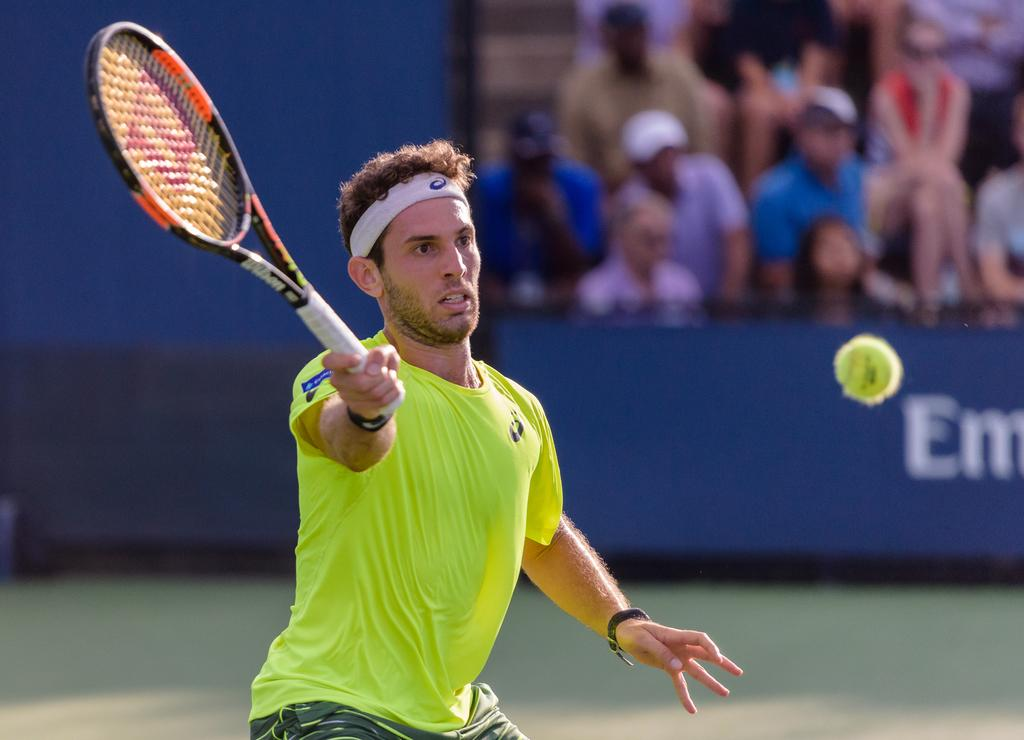What activity is the person in the image engaged in? The person is playing tennis in the image. What is the tennis ball doing in the image? The tennis ball is flying in the air. How is the person holding the tennis bat? The person is holding the tennis bat with their right hand. What can be observed about the background of the person in the image? The background of the person is blurred. What type of riddle is the person solving in the image? There is no riddle present in the image; the person is playing tennis. What musical instrument is the person playing in the image? The person is not playing a musical instrument in the image; they are playing tennis with a tennis bat. 